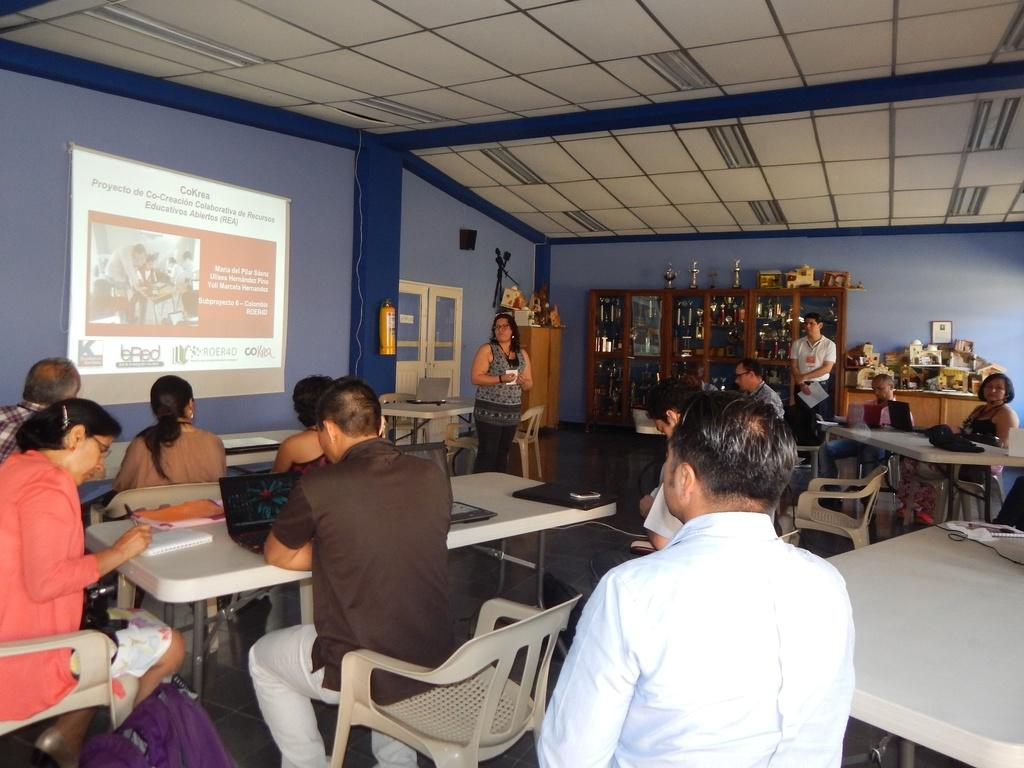What are the people in the image doing? There are people sitting on chairs in the image. Are there any other people in the image besides those sitting on chairs? Yes, there are two people standing in the image. What can be seen on the wall or screen in the image? There is a projector screen in the image. What type of scissors are being used to cut the road in the image? There are no scissors or roads present in the image. How does the image depict the concept of change? The image does not depict the concept of change; it shows people sitting on chairs, standing, and a projector screen. 